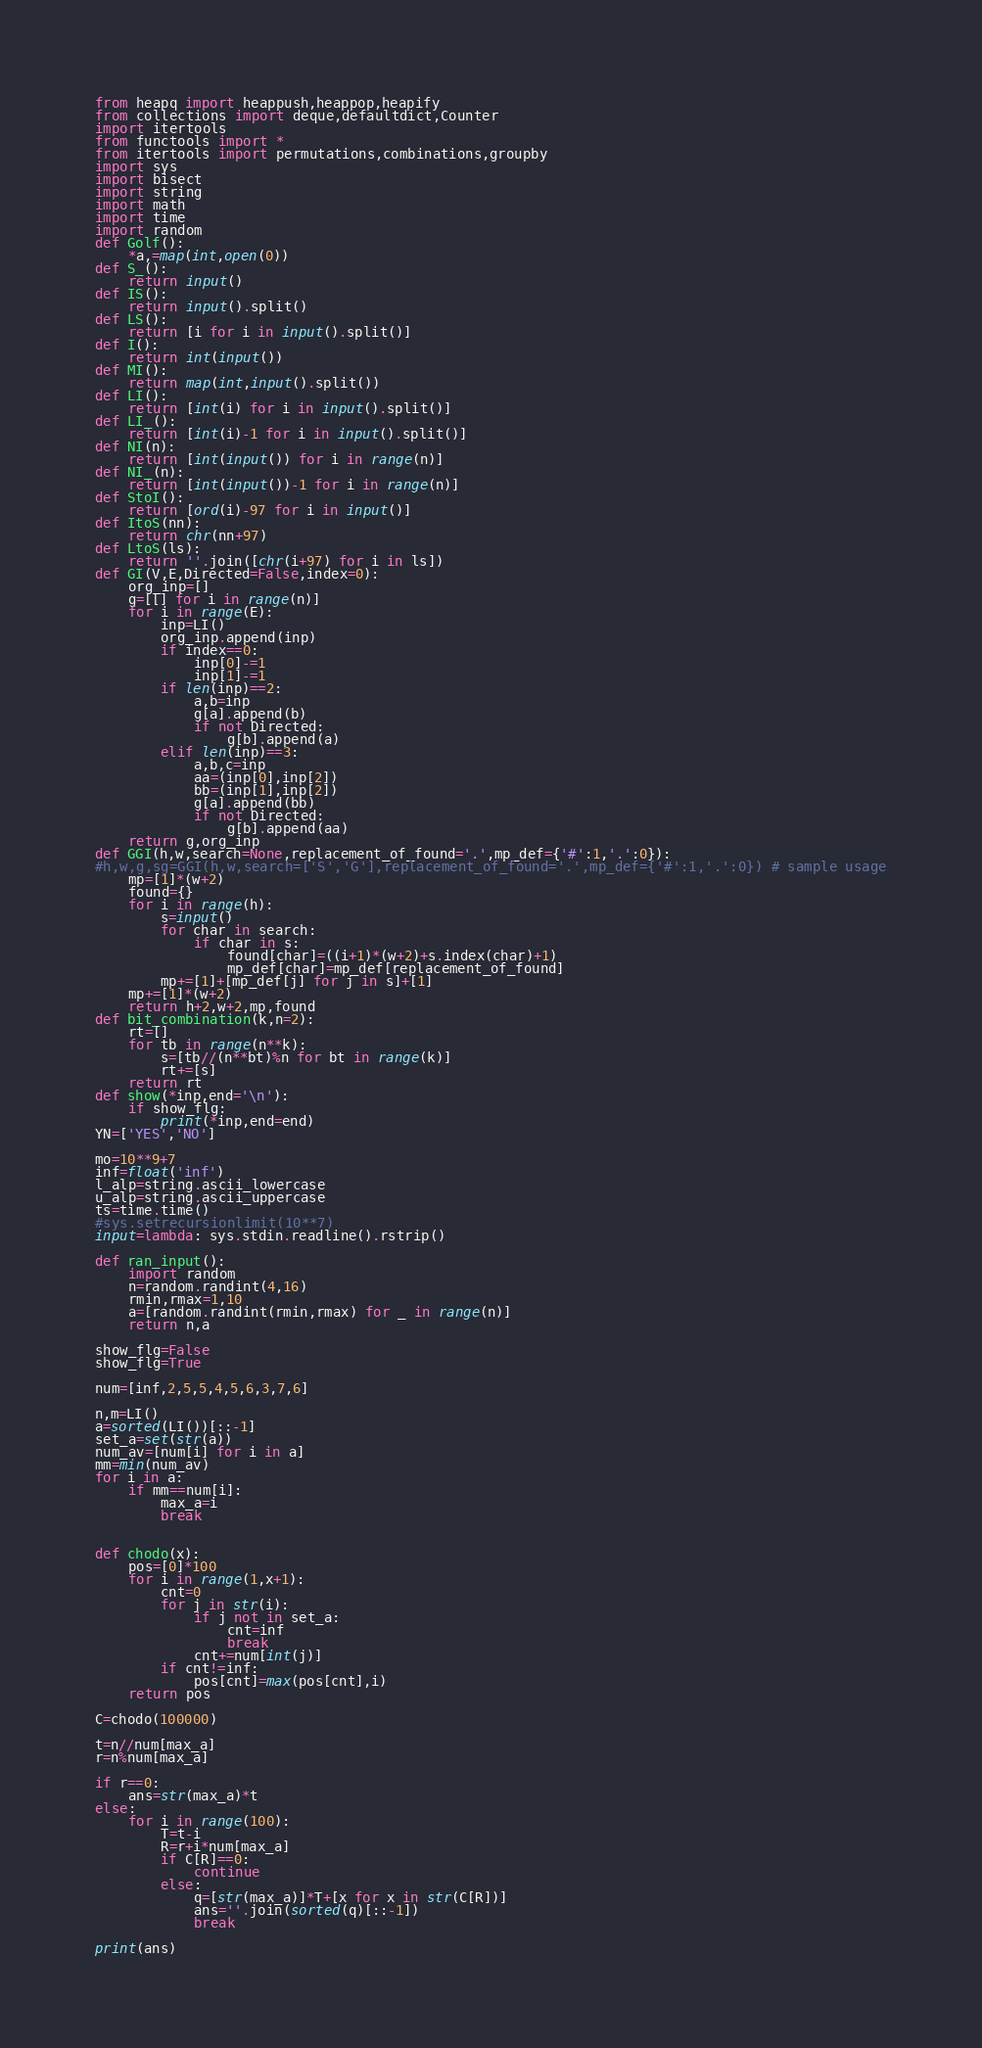Convert code to text. <code><loc_0><loc_0><loc_500><loc_500><_Python_>from heapq import heappush,heappop,heapify
from collections import deque,defaultdict,Counter
import itertools
from functools import *
from itertools import permutations,combinations,groupby
import sys
import bisect
import string
import math
import time
import random
def Golf():
    *a,=map(int,open(0))
def S_():
    return input()
def IS():
    return input().split()
def LS():
    return [i for i in input().split()]
def I():
    return int(input())
def MI():
    return map(int,input().split())
def LI():
    return [int(i) for i in input().split()]
def LI_():
    return [int(i)-1 for i in input().split()]
def NI(n):
    return [int(input()) for i in range(n)]
def NI_(n):
    return [int(input())-1 for i in range(n)]
def StoI():
    return [ord(i)-97 for i in input()]
def ItoS(nn):
    return chr(nn+97)
def LtoS(ls):
    return ''.join([chr(i+97) for i in ls])
def GI(V,E,Directed=False,index=0):
    org_inp=[]
    g=[[] for i in range(n)]
    for i in range(E):
        inp=LI()
        org_inp.append(inp)
        if index==0:
            inp[0]-=1
            inp[1]-=1
        if len(inp)==2:
            a,b=inp
            g[a].append(b)
            if not Directed:
                g[b].append(a)
        elif len(inp)==3:
            a,b,c=inp
            aa=(inp[0],inp[2])
            bb=(inp[1],inp[2])
            g[a].append(bb)
            if not Directed:
                g[b].append(aa)
    return g,org_inp
def GGI(h,w,search=None,replacement_of_found='.',mp_def={'#':1,'.':0}):
#h,w,g,sg=GGI(h,w,search=['S','G'],replacement_of_found='.',mp_def={'#':1,'.':0}) # sample usage
    mp=[1]*(w+2)
    found={}
    for i in range(h):
        s=input()
        for char in search:
            if char in s:
                found[char]=((i+1)*(w+2)+s.index(char)+1)
                mp_def[char]=mp_def[replacement_of_found]
        mp+=[1]+[mp_def[j] for j in s]+[1]
    mp+=[1]*(w+2)
    return h+2,w+2,mp,found
def bit_combination(k,n=2):
    rt=[]
    for tb in range(n**k):
        s=[tb//(n**bt)%n for bt in range(k)]
        rt+=[s]
    return rt
def show(*inp,end='\n'):
    if show_flg:
        print(*inp,end=end)
YN=['YES','NO']

mo=10**9+7
inf=float('inf')
l_alp=string.ascii_lowercase
u_alp=string.ascii_uppercase
ts=time.time()
#sys.setrecursionlimit(10**7)
input=lambda: sys.stdin.readline().rstrip()
 
def ran_input():
    import random
    n=random.randint(4,16)
    rmin,rmax=1,10
    a=[random.randint(rmin,rmax) for _ in range(n)]
    return n,a

show_flg=False
show_flg=True

num=[inf,2,5,5,4,5,6,3,7,6]

n,m=LI()
a=sorted(LI())[::-1]
set_a=set(str(a))
num_av=[num[i] for i in a]
mm=min(num_av)
for i in a:
    if mm==num[i]:
        max_a=i
        break


def chodo(x):
    pos=[0]*100
    for i in range(1,x+1):
        cnt=0
        for j in str(i):
            if j not in set_a:
                cnt=inf
                break
            cnt+=num[int(j)]
        if cnt!=inf:
            pos[cnt]=max(pos[cnt],i)
    return pos

C=chodo(100000)

t=n//num[max_a]
r=n%num[max_a]

if r==0:
    ans=str(max_a)*t
else:
    for i in range(100):
        T=t-i
        R=r+i*num[max_a]
        if C[R]==0:
            continue
        else:
            q=[str(max_a)]*T+[x for x in str(C[R])]
            ans=''.join(sorted(q)[::-1])
            break

print(ans)
</code> 